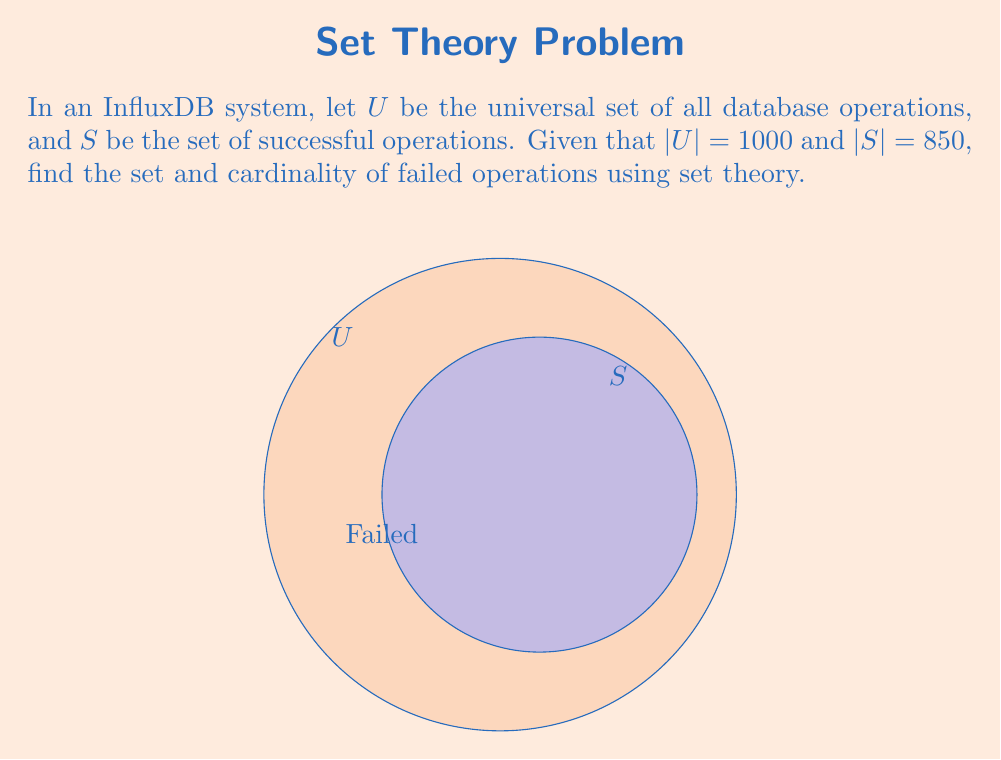What is the answer to this math problem? Let's approach this step-by-step:

1) The set of failed operations is the complement of the set of successful operations within the universal set. We can represent this as $S^c$ or $U \setminus S$.

2) In set theory, for any set $A$ that is a subset of a universal set $U$, we have:

   $$|A^c| = |U| - |A|$$

3) In this case:
   $U$ is the universal set of all operations
   $S$ is the set of successful operations
   $S^c$ is the set of failed operations

4) We're given:
   $|U| = 1000$
   $|S| = 850$

5) Applying the formula:

   $$|S^c| = |U| - |S| = 1000 - 850 = 150$$

6) Therefore, the cardinality of the set of failed operations is 150.

7) The set of failed operations can be described as:

   $$S^c = \{x \in U : x \notin S\}$$

   Which reads as "the set of all elements $x$ in $U$ such that $x$ is not in $S$".
Answer: $S^c = \{x \in U : x \notin S\}$, $|S^c| = 150$ 